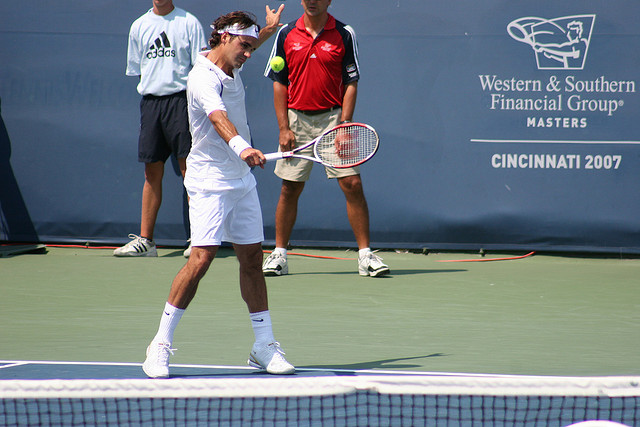Identify the text displayed in this image. CINCINNATI MASTERS Financial WESTERN 2007 GROUP Southern &amp; addos 